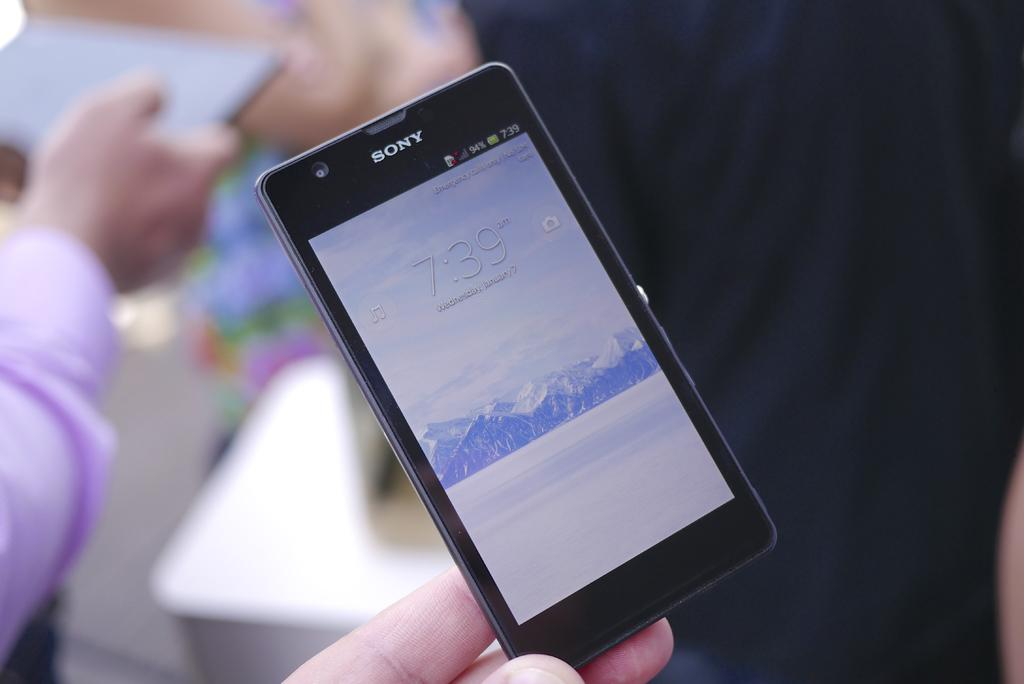<image>
Present a compact description of the photo's key features. A black Sony device shows the time of 7:39. 